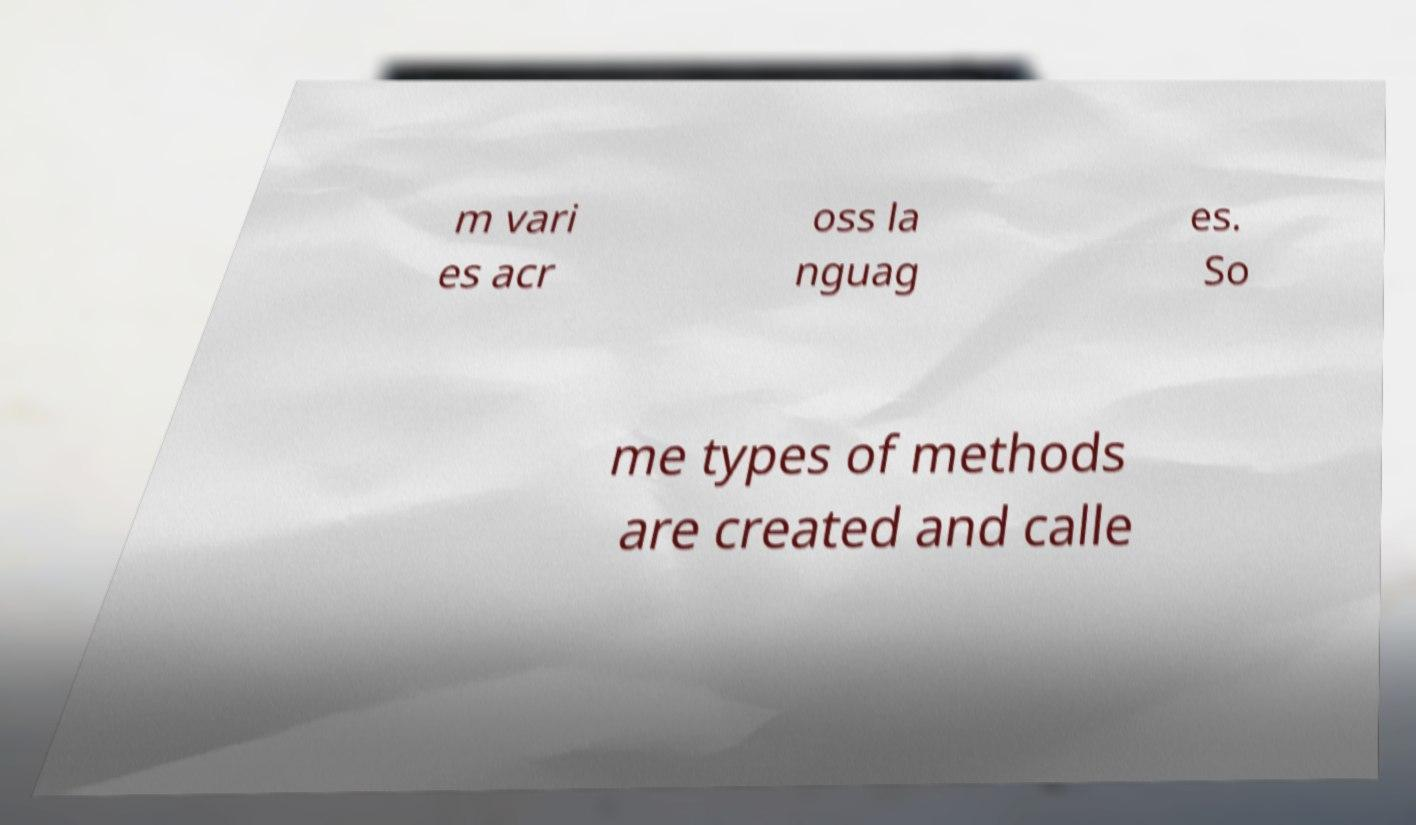There's text embedded in this image that I need extracted. Can you transcribe it verbatim? m vari es acr oss la nguag es. So me types of methods are created and calle 